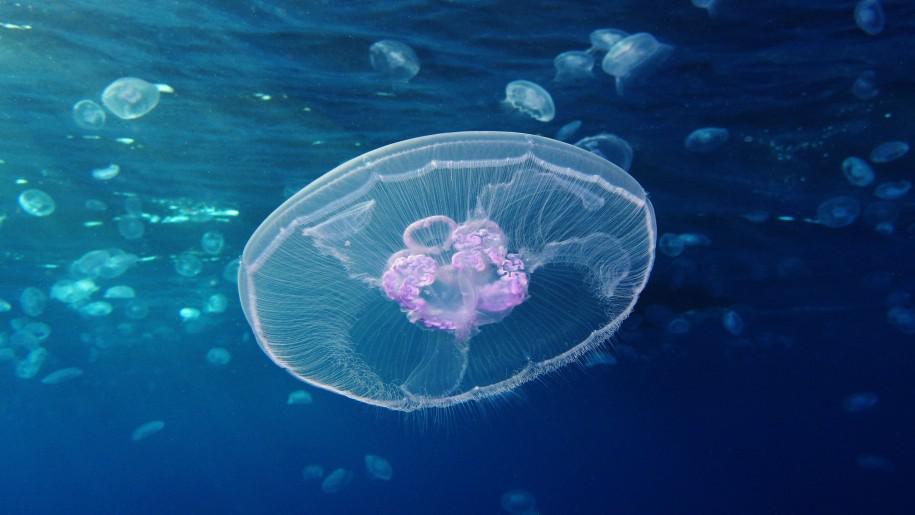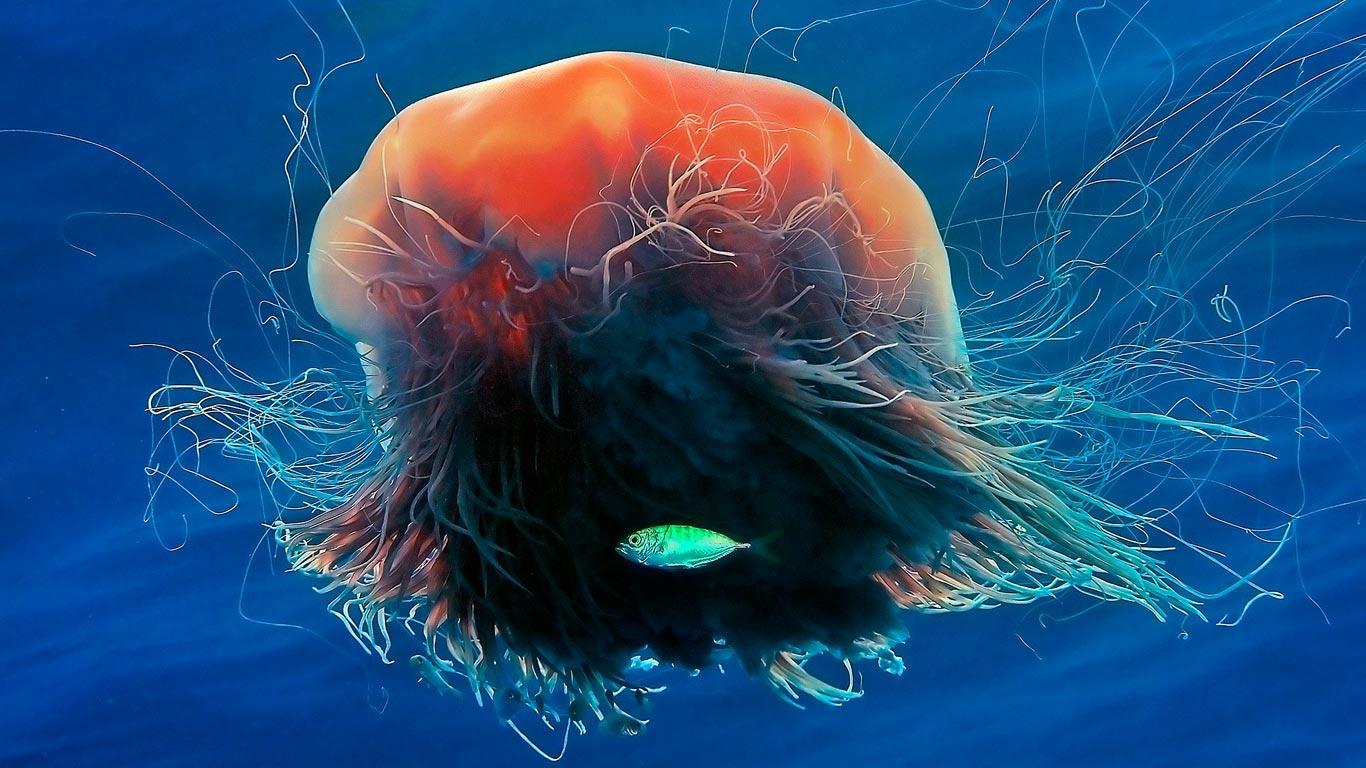The first image is the image on the left, the second image is the image on the right. Assess this claim about the two images: "A woman in a swimsuit is in the water near a jellyfish in the right image, and the left image features one jellyfish with tentacles trailing horizontally.". Correct or not? Answer yes or no. No. The first image is the image on the left, the second image is the image on the right. Considering the images on both sides, is "A woman in a swimsuit swims in the water near at least one jellyfish in the image on the right." valid? Answer yes or no. No. 